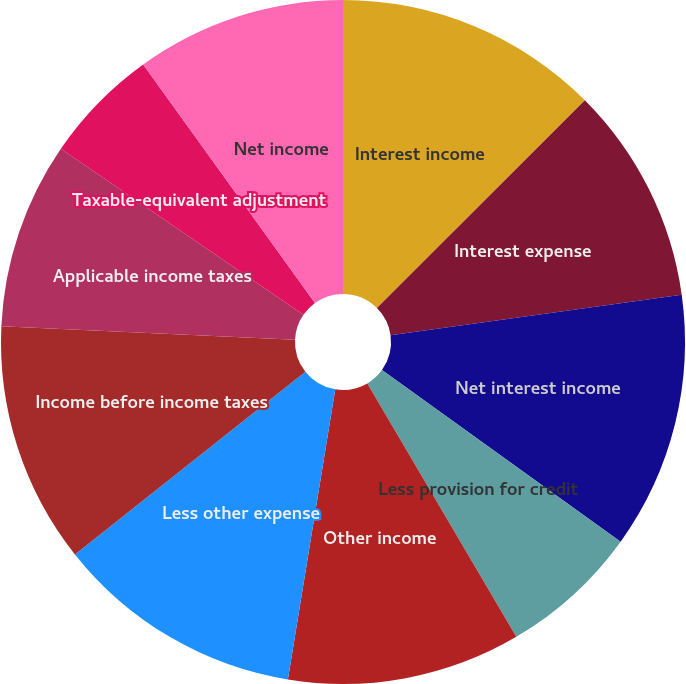Convert chart to OTSL. <chart><loc_0><loc_0><loc_500><loc_500><pie_chart><fcel>Interest income<fcel>Interest expense<fcel>Net interest income<fcel>Less provision for credit<fcel>Other income<fcel>Less other expense<fcel>Income before income taxes<fcel>Applicable income taxes<fcel>Taxable-equivalent adjustment<fcel>Net income<nl><fcel>12.5%<fcel>10.29%<fcel>12.13%<fcel>6.62%<fcel>11.03%<fcel>11.76%<fcel>11.4%<fcel>8.82%<fcel>5.51%<fcel>9.93%<nl></chart> 